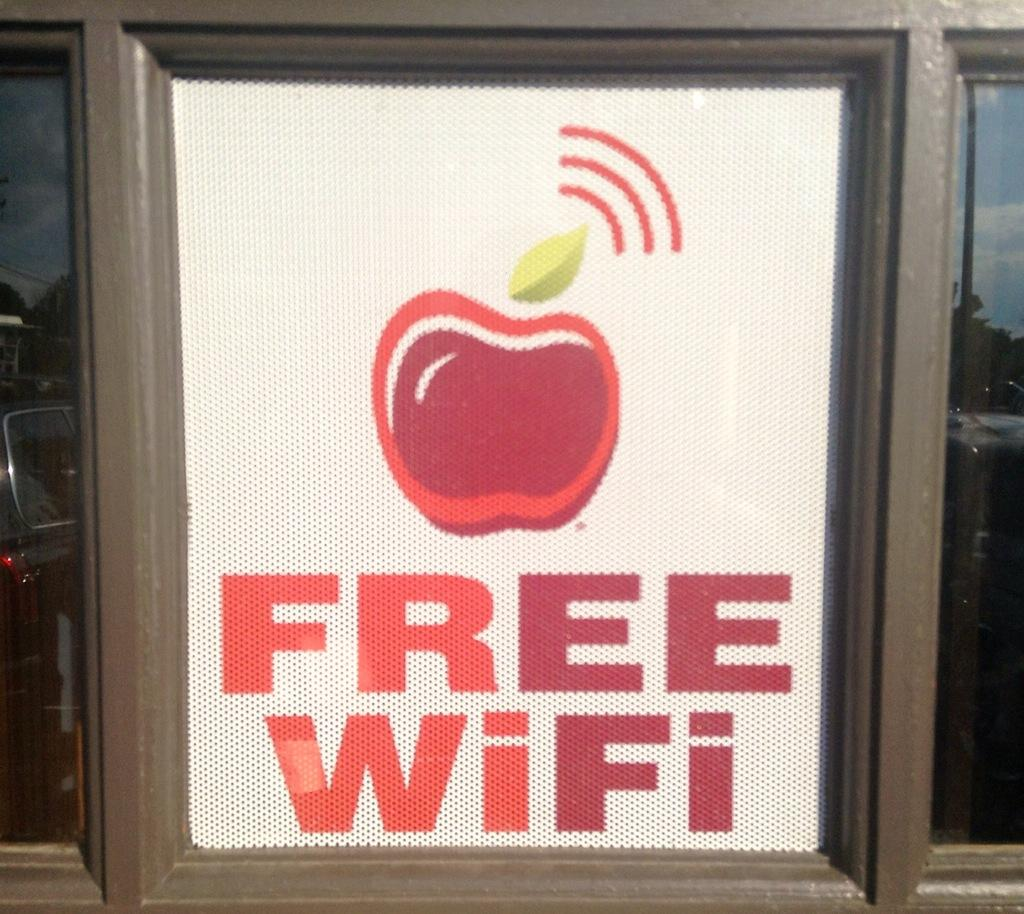What object is present in the image that can hold a liquid? There is a glass in the image that can hold a liquid. Is there any additional decoration or feature on the glass? Yes, there is a sticker on the glass. Where is the brother's face in the image? There is no brother or face present in the image; it only features a glass with a sticker on it. 